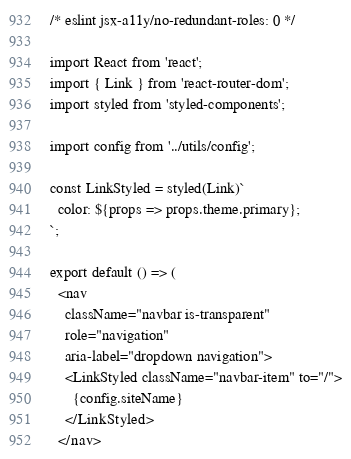Convert code to text. <code><loc_0><loc_0><loc_500><loc_500><_JavaScript_>/* eslint jsx-a11y/no-redundant-roles: 0 */

import React from 'react';
import { Link } from 'react-router-dom';
import styled from 'styled-components';

import config from '../utils/config';

const LinkStyled = styled(Link)`
  color: ${props => props.theme.primary};
`;

export default () => (
  <nav
    className="navbar is-transparent"
    role="navigation"
    aria-label="dropdown navigation">
    <LinkStyled className="navbar-item" to="/">
      {config.siteName}
    </LinkStyled>
  </nav></code> 